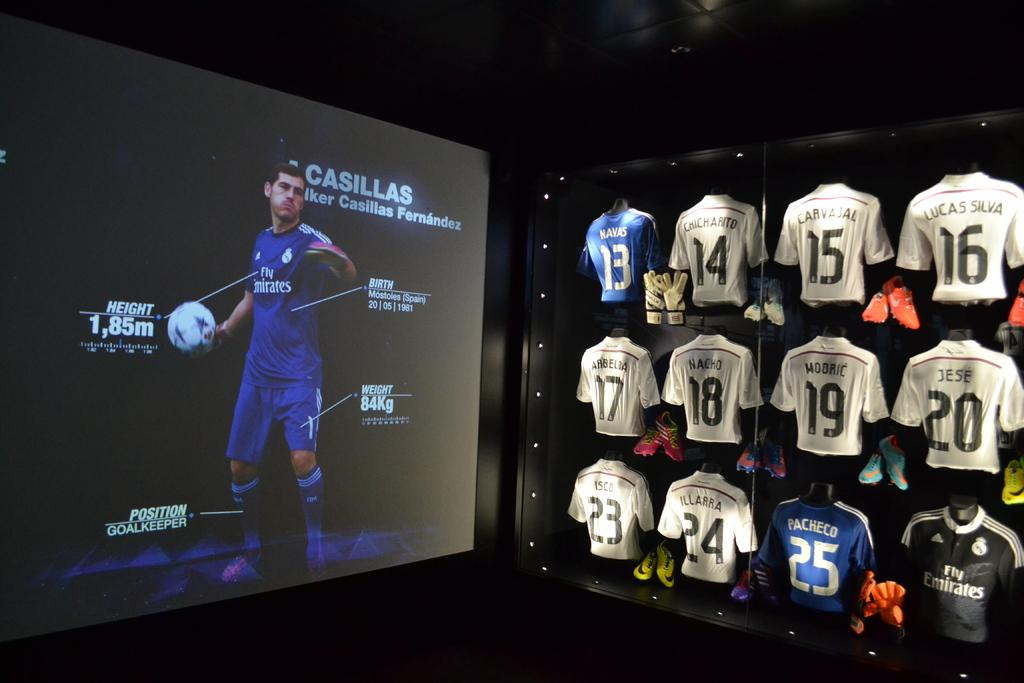<image>
Share a concise interpretation of the image provided. A display glass of jerseys in white and the only blue one has the number 13. 